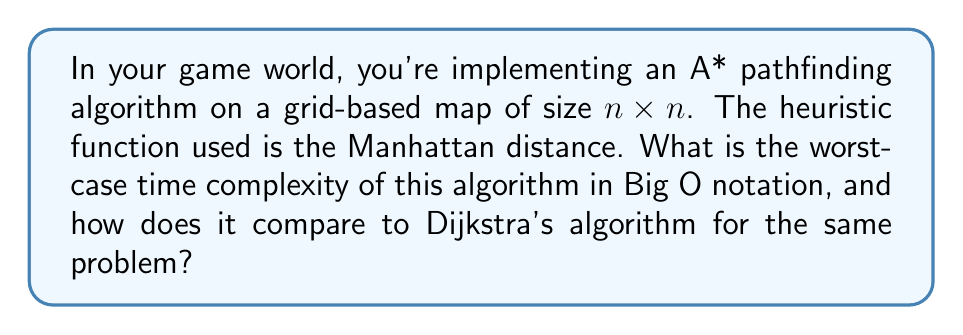Can you answer this question? To analyze the time complexity of the A* algorithm in this scenario, we need to consider the following factors:

1. Size of the search space: The grid is $n \times n$, so there are $n^2$ total nodes.

2. Priority queue operations: A* uses a priority queue to select the next node to expand. In the worst case, we might need to add and remove each node from the queue.

3. Heuristic function: The Manhattan distance can be calculated in constant time $O(1)$.

4. Neighbor generation: Each node has at most 4 neighbors (up, down, left, right) in a grid-based map.

The worst-case scenario occurs when the algorithm needs to explore all nodes before finding the goal. In this case:

1. Each node is added to and removed from the priority queue once: $O(n^2 \log n^2)$ = $O(n^2 \log n)$
   (using a binary heap implementation of the priority queue)

2. For each node, we perform constant-time operations (heuristic calculation, neighbor generation): $O(n^2)$

Therefore, the total worst-case time complexity is:

$$O(n^2 \log n + n^2) = O(n^2 \log n)$$

Comparison with Dijkstra's algorithm:
Dijkstra's algorithm has the same worst-case time complexity of $O(n^2 \log n)$ for a grid-based map using a binary heap priority queue. However, A* is generally faster in practice due to its heuristic function guiding the search towards the goal, resulting in fewer node expansions on average.

The space complexity for both algorithms is $O(n^2)$ to store the grid and the priority queue.
Answer: The worst-case time complexity of the A* pathfinding algorithm on an $n \times n$ grid-based map is $O(n^2 \log n)$, which is the same as Dijkstra's algorithm in this scenario. However, A* is often more efficient in practice due to its use of a heuristic function. 